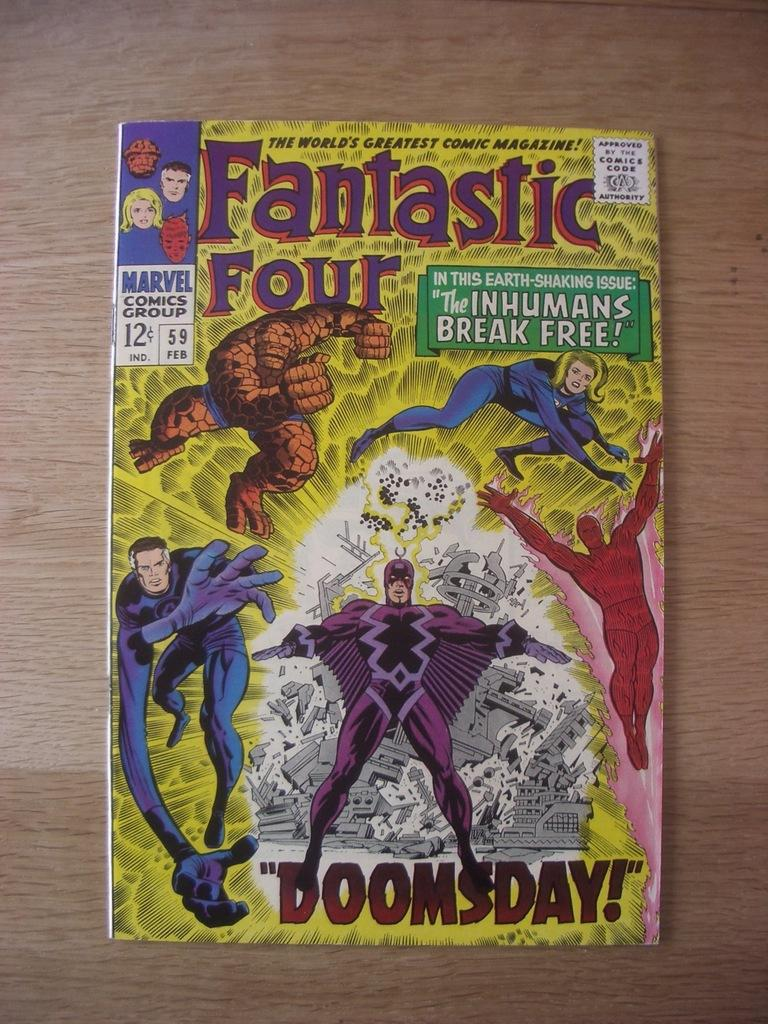Provide a one-sentence caption for the provided image. A fantastic four comic book titled Doomsday from Marvel. 